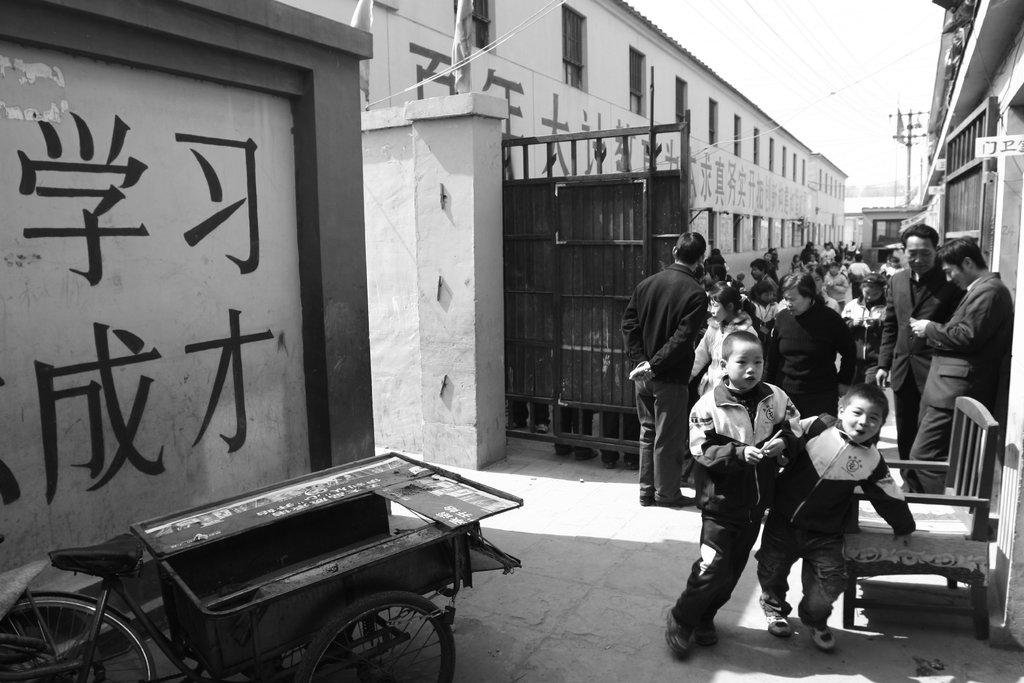How many people are in the image? There is a group of people in the image. What are the people in the image doing? The people are standing. Can you describe any furniture in the image? There is a chair in the image. What type of structure can be seen in the image? There is at least one building in the image. What type of cactus is on the table in the image? There is no cactus present in the image. What type of wine is being served to the people in the image? There is no wine present in the image. 